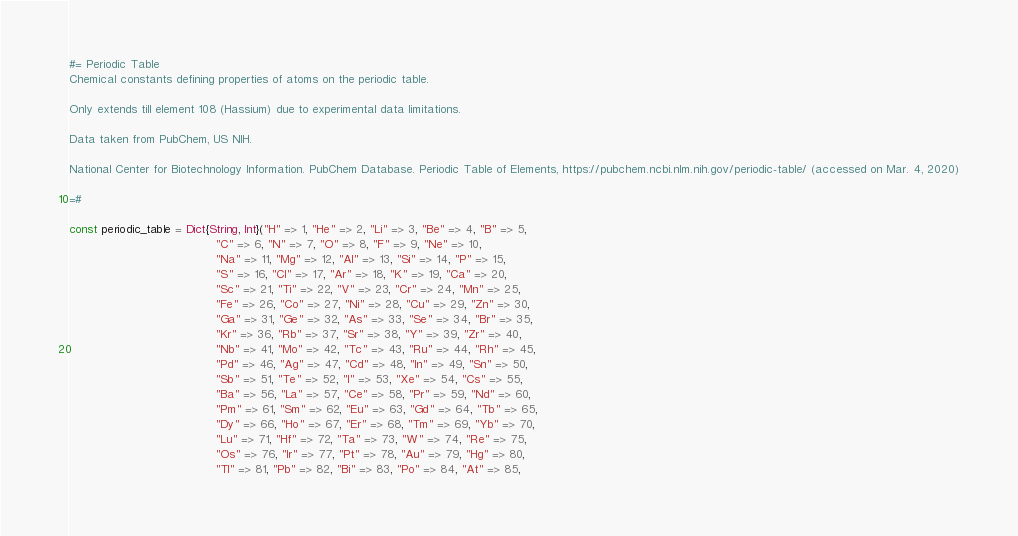<code> <loc_0><loc_0><loc_500><loc_500><_Julia_>#= Periodic Table
Chemical constants defining properties of atoms on the periodic table.

Only extends till element 108 (Hassium) due to experimental data limitations.

Data taken from PubChem, US NIH.

National Center for Biotechnology Information. PubChem Database. Periodic Table of Elements, https://pubchem.ncbi.nlm.nih.gov/periodic-table/ (accessed on Mar. 4, 2020)

=#

const periodic_table = Dict{String, Int}("H" => 1, "He" => 2, "Li" => 3, "Be" => 4, "B" => 5,
                                         "C" => 6, "N" => 7, "O" => 8, "F" => 9, "Ne" => 10,
                                         "Na" => 11, "Mg" => 12, "Al" => 13, "Si" => 14, "P" => 15,
                                         "S" => 16, "Cl" => 17, "Ar" => 18, "K" => 19, "Ca" => 20,
                                         "Sc" => 21, "Ti" => 22, "V" => 23, "Cr" => 24, "Mn" => 25,
                                         "Fe" => 26, "Co" => 27, "Ni" => 28, "Cu" => 29, "Zn" => 30,
                                         "Ga" => 31, "Ge" => 32, "As" => 33, "Se" => 34, "Br" => 35,
                                         "Kr" => 36, "Rb" => 37, "Sr" => 38, "Y" => 39, "Zr" => 40,
                                         "Nb" => 41, "Mo" => 42, "Tc" => 43, "Ru" => 44, "Rh" => 45,
                                         "Pd" => 46, "Ag" => 47, "Cd" => 48, "In" => 49, "Sn" => 50,
                                         "Sb" => 51, "Te" => 52, "I" => 53, "Xe" => 54, "Cs" => 55,
                                         "Ba" => 56, "La" => 57, "Ce" => 58, "Pr" => 59, "Nd" => 60,
                                         "Pm" => 61, "Sm" => 62, "Eu" => 63, "Gd" => 64, "Tb" => 65,
                                         "Dy" => 66, "Ho" => 67, "Er" => 68, "Tm" => 69, "Yb" => 70,
                                         "Lu" => 71, "Hf" => 72, "Ta" => 73, "W" => 74, "Re" => 75,
                                         "Os" => 76, "Ir" => 77, "Pt" => 78, "Au" => 79, "Hg" => 80,
                                         "Tl" => 81, "Pb" => 82, "Bi" => 83, "Po" => 84, "At" => 85,</code> 